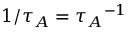<formula> <loc_0><loc_0><loc_500><loc_500>1 / { \tau _ { A } } = { \tau _ { A } } ^ { - 1 }</formula> 